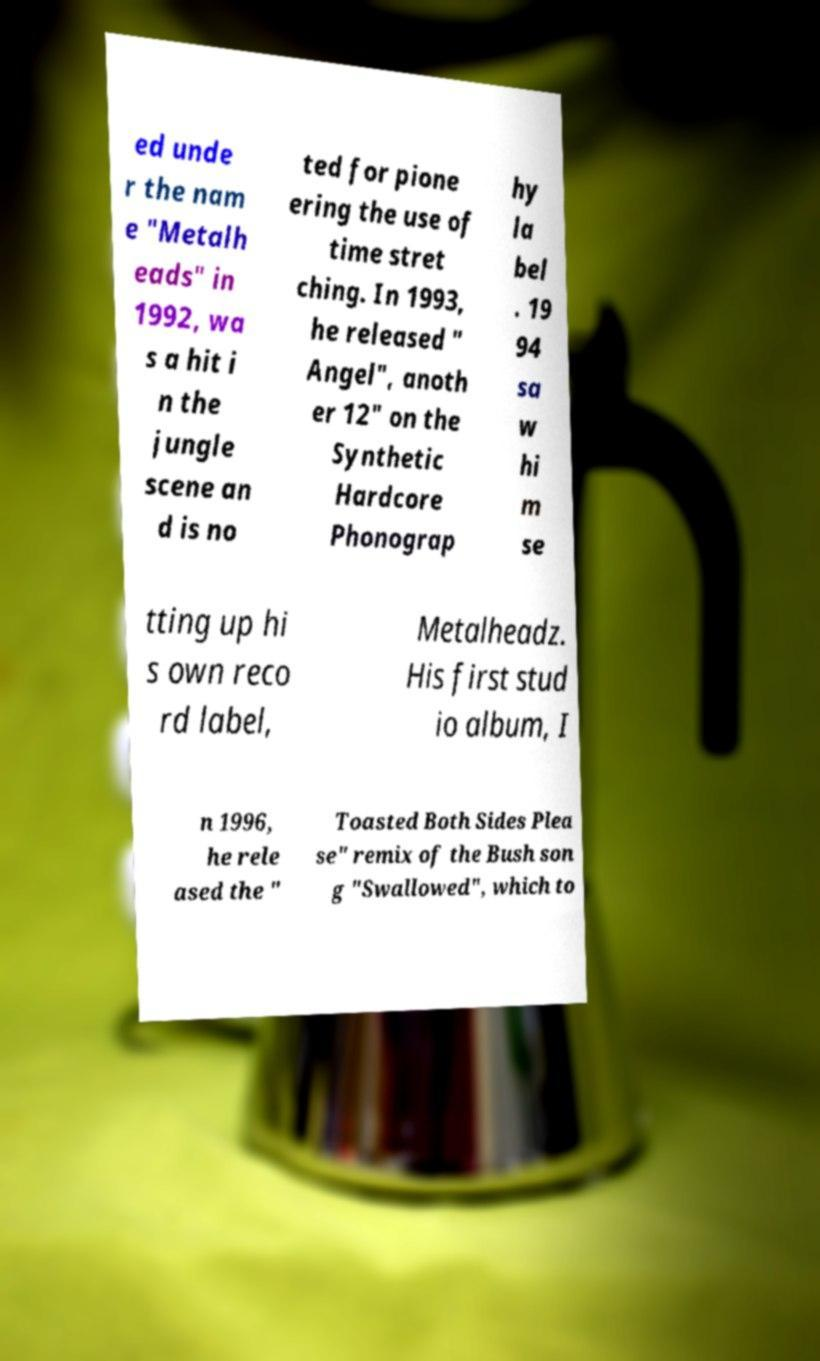What messages or text are displayed in this image? I need them in a readable, typed format. ed unde r the nam e "Metalh eads" in 1992, wa s a hit i n the jungle scene an d is no ted for pione ering the use of time stret ching. In 1993, he released " Angel", anoth er 12" on the Synthetic Hardcore Phonograp hy la bel . 19 94 sa w hi m se tting up hi s own reco rd label, Metalheadz. His first stud io album, I n 1996, he rele ased the " Toasted Both Sides Plea se" remix of the Bush son g "Swallowed", which to 